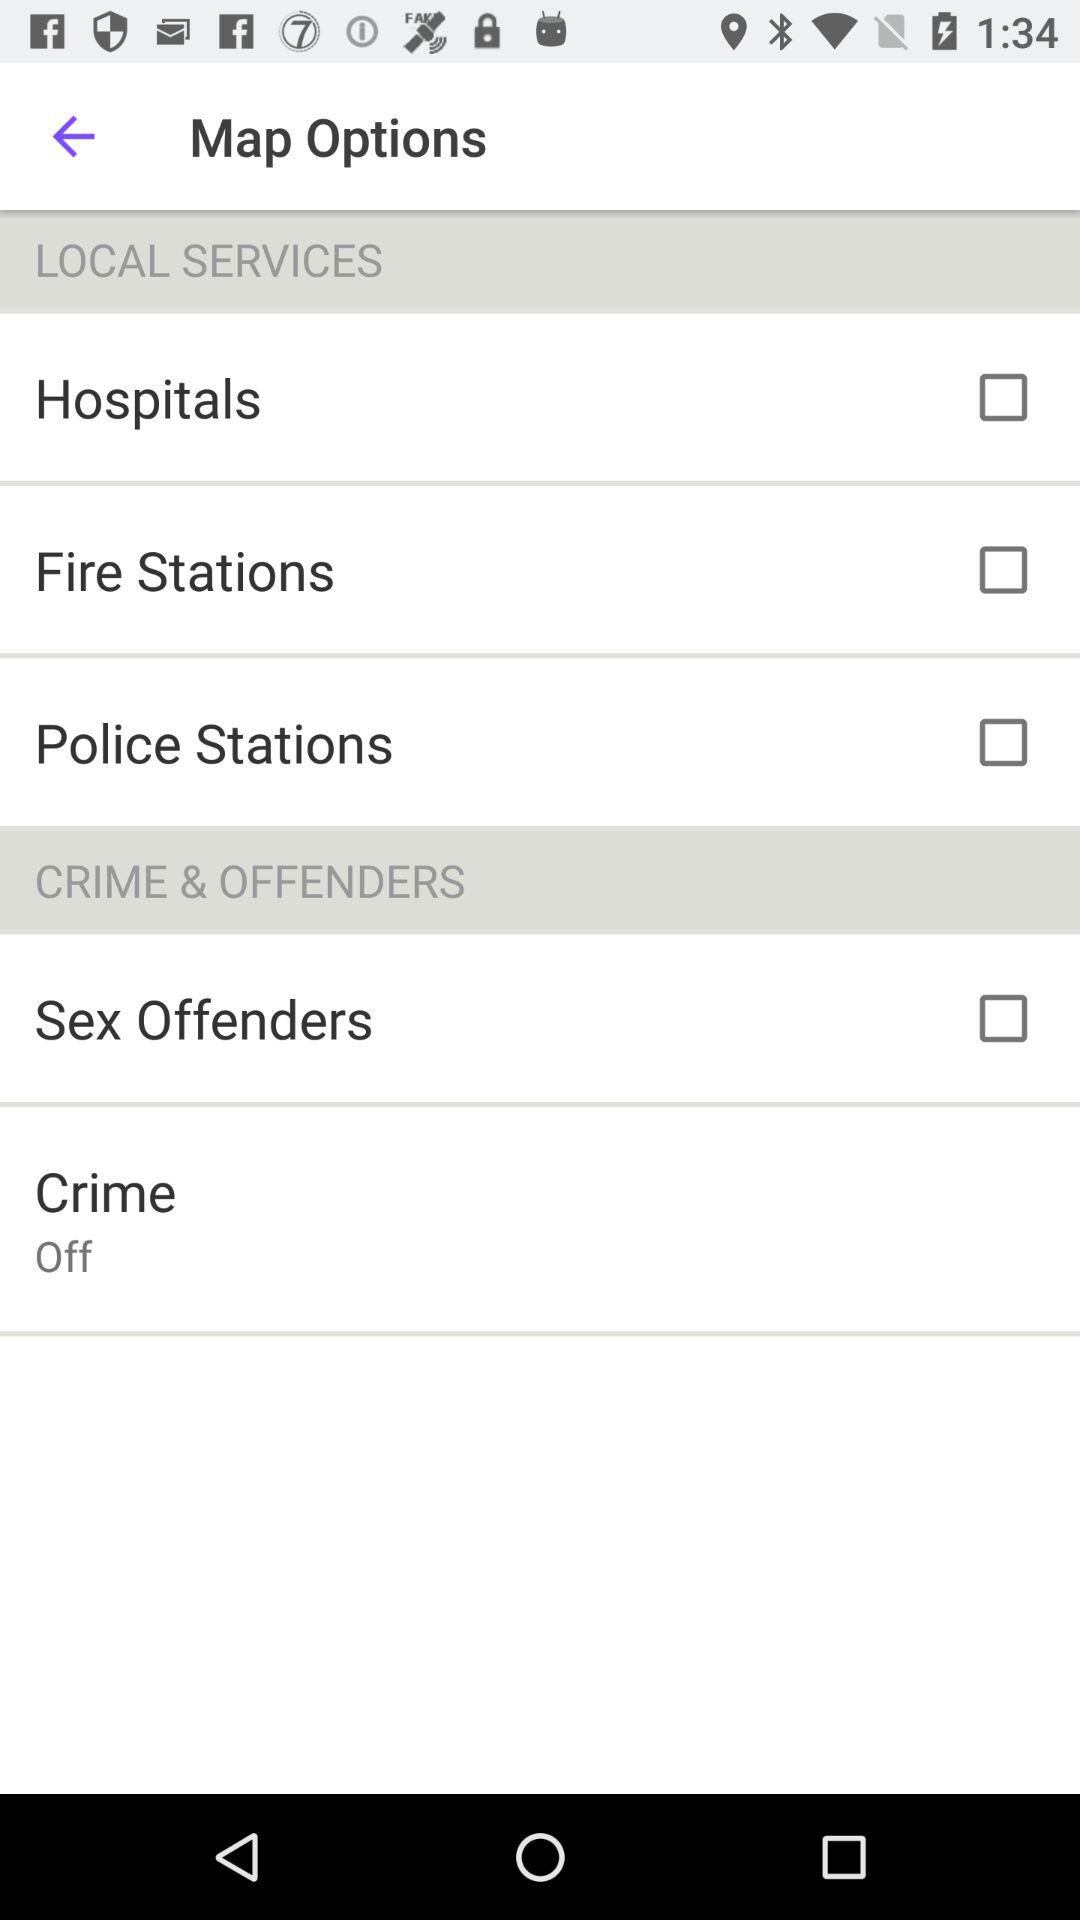What is the status of "Hospitals"? The status of "Hospitals" is "off". 